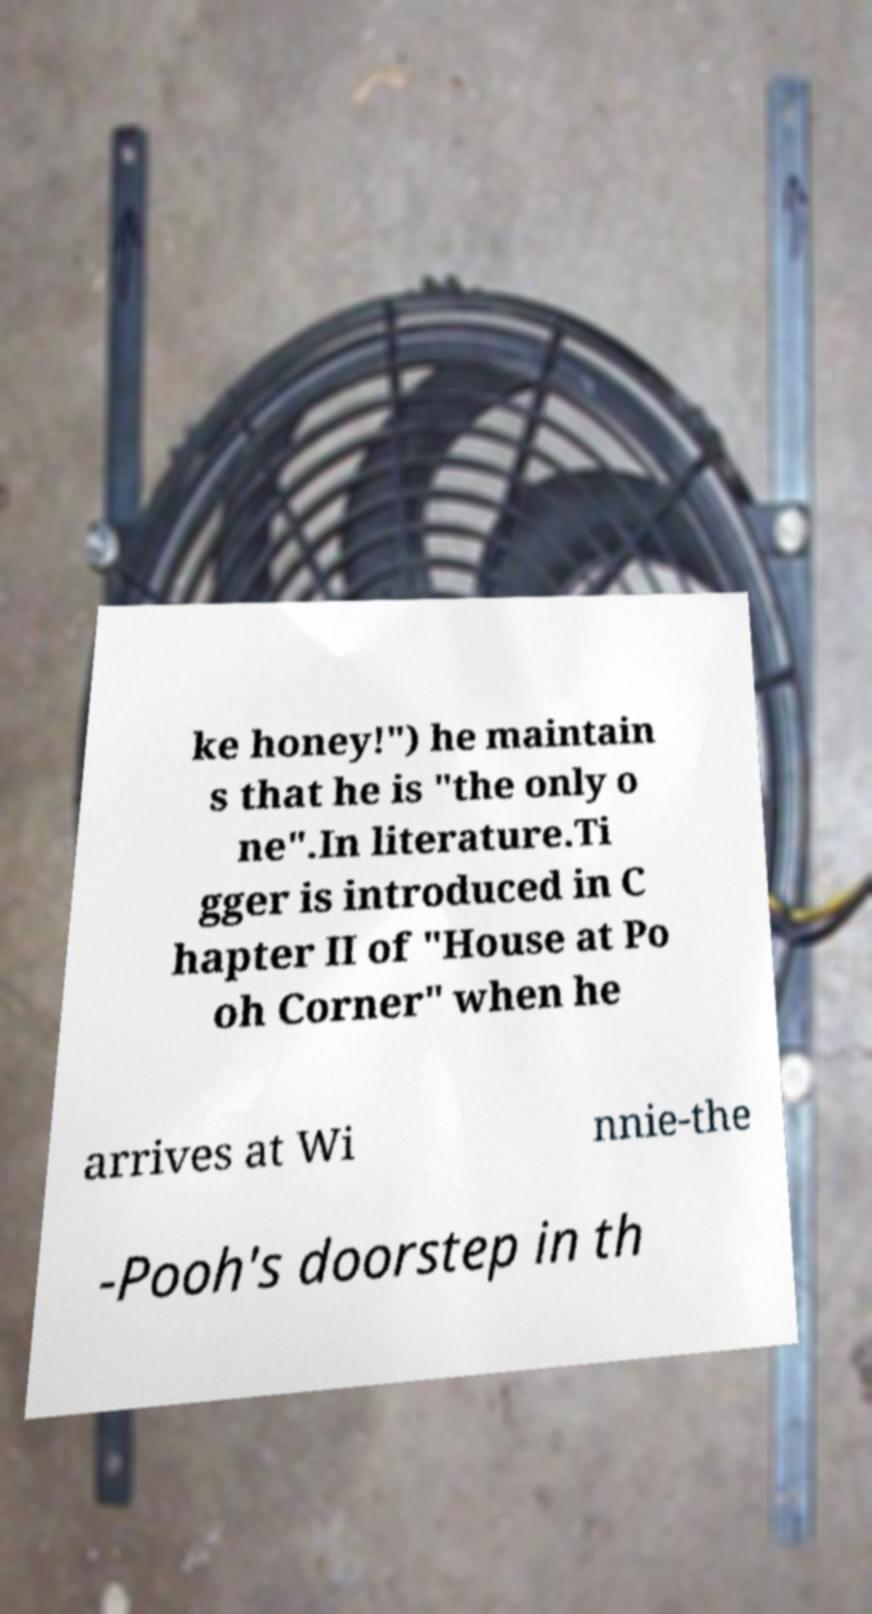There's text embedded in this image that I need extracted. Can you transcribe it verbatim? ke honey!") he maintain s that he is "the only o ne".In literature.Ti gger is introduced in C hapter II of "House at Po oh Corner" when he arrives at Wi nnie-the -Pooh's doorstep in th 